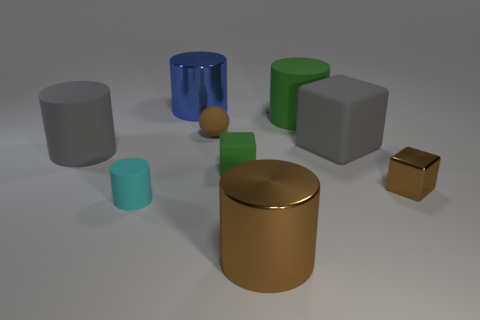There is a rubber block to the left of the big metallic cylinder in front of the tiny thing on the left side of the tiny rubber ball; what color is it?
Provide a succinct answer. Green. Is the number of brown spheres to the left of the tiny matte ball the same as the number of brown balls?
Offer a terse response. No. Is there any other thing that is the same material as the large brown cylinder?
Make the answer very short. Yes. Is the color of the tiny matte sphere the same as the big cylinder in front of the small metallic block?
Offer a terse response. Yes. There is a green object that is in front of the object to the left of the tiny cylinder; are there any matte cylinders to the right of it?
Make the answer very short. Yes. Are there fewer big blocks that are in front of the tiny green object than big objects?
Provide a short and direct response. Yes. How many other things are the same shape as the tiny cyan object?
Provide a succinct answer. 4. What number of things are either metallic objects that are behind the cyan matte cylinder or small balls behind the cyan matte thing?
Make the answer very short. 3. There is a brown thing that is behind the brown cylinder and in front of the brown sphere; what size is it?
Provide a short and direct response. Small. Do the big green rubber thing that is behind the big gray block and the big brown shiny thing have the same shape?
Keep it short and to the point. Yes. 